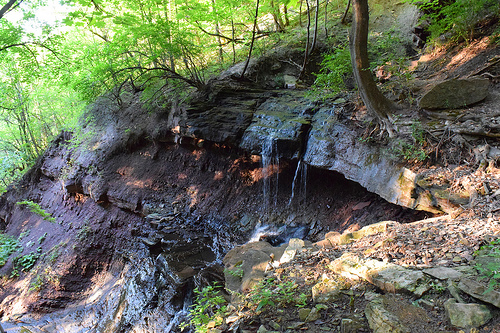<image>
Is there a waterway in the forest? Yes. The waterway is contained within or inside the forest, showing a containment relationship. 